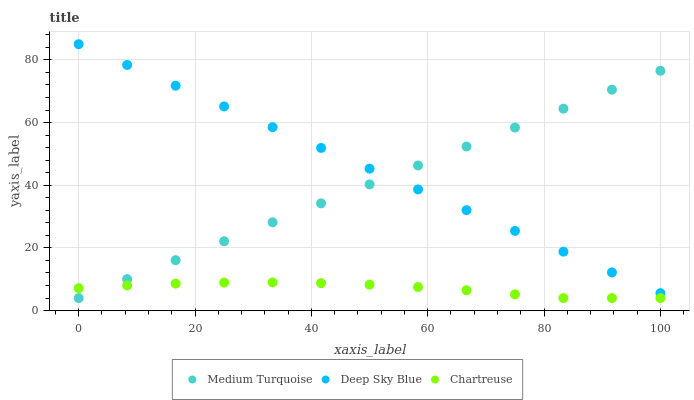Does Chartreuse have the minimum area under the curve?
Answer yes or no. Yes. Does Deep Sky Blue have the maximum area under the curve?
Answer yes or no. Yes. Does Medium Turquoise have the minimum area under the curve?
Answer yes or no. No. Does Medium Turquoise have the maximum area under the curve?
Answer yes or no. No. Is Medium Turquoise the smoothest?
Answer yes or no. Yes. Is Chartreuse the roughest?
Answer yes or no. Yes. Is Deep Sky Blue the smoothest?
Answer yes or no. No. Is Deep Sky Blue the roughest?
Answer yes or no. No. Does Chartreuse have the lowest value?
Answer yes or no. Yes. Does Deep Sky Blue have the lowest value?
Answer yes or no. No. Does Deep Sky Blue have the highest value?
Answer yes or no. Yes. Does Medium Turquoise have the highest value?
Answer yes or no. No. Is Chartreuse less than Deep Sky Blue?
Answer yes or no. Yes. Is Deep Sky Blue greater than Chartreuse?
Answer yes or no. Yes. Does Chartreuse intersect Medium Turquoise?
Answer yes or no. Yes. Is Chartreuse less than Medium Turquoise?
Answer yes or no. No. Is Chartreuse greater than Medium Turquoise?
Answer yes or no. No. Does Chartreuse intersect Deep Sky Blue?
Answer yes or no. No. 